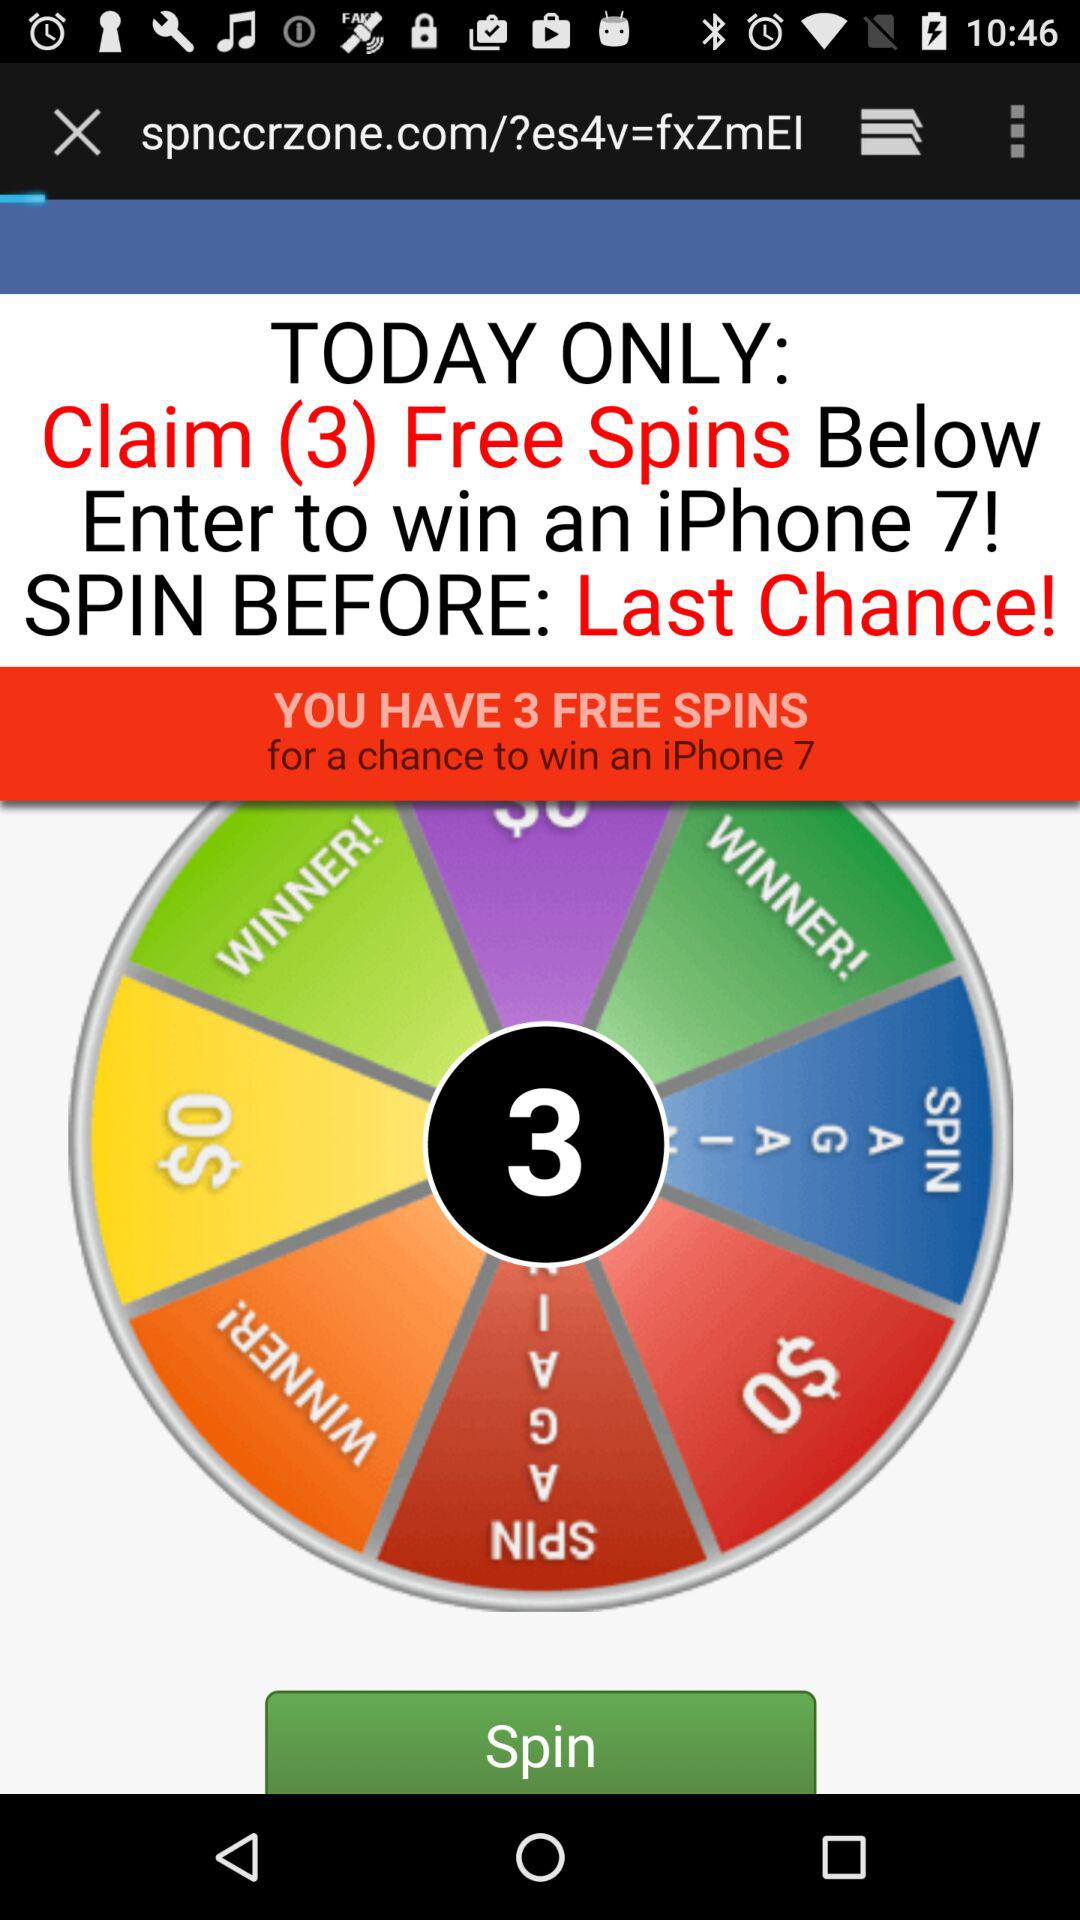What gift item do we have a chance to win? You have a chance to win an iPhone 7. 